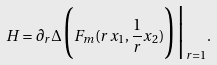<formula> <loc_0><loc_0><loc_500><loc_500>H = \partial _ { r } \Delta \Big ( F _ { m } ( r x _ { 1 } , \frac { 1 } { r } x _ { 2 } ) \Big ) \Big | _ { r = 1 } .</formula> 